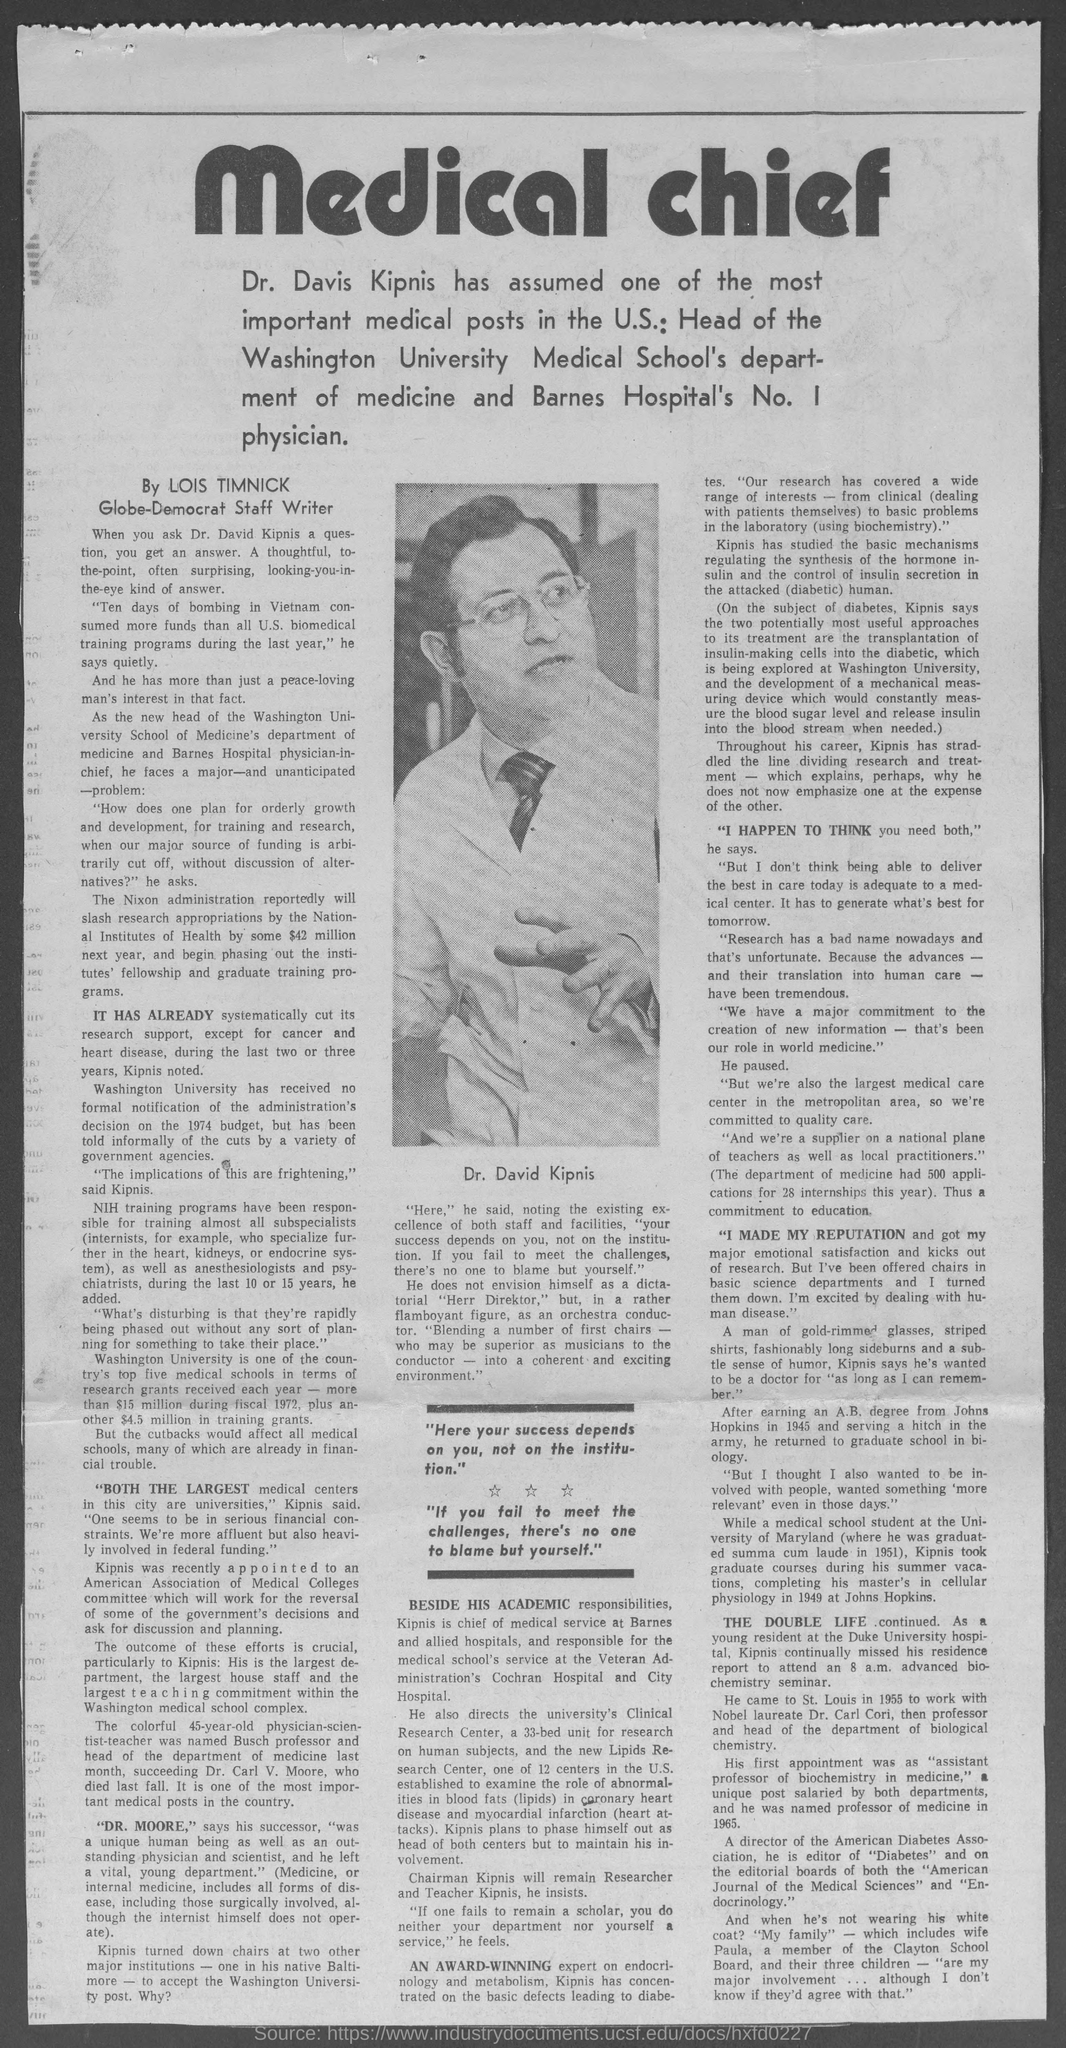Mention a couple of crucial points in this snapshot. I, Dr. David Kipnis, quoted, 'If you fail to meet the challenges, there's no one to blame but yourself.' Washington University is one of the top five medical schools in the country in terms of the number of research grants it receives annually. The declaration states that the picture shown in the newspaper is of a person named Dr. David Kipnis. 